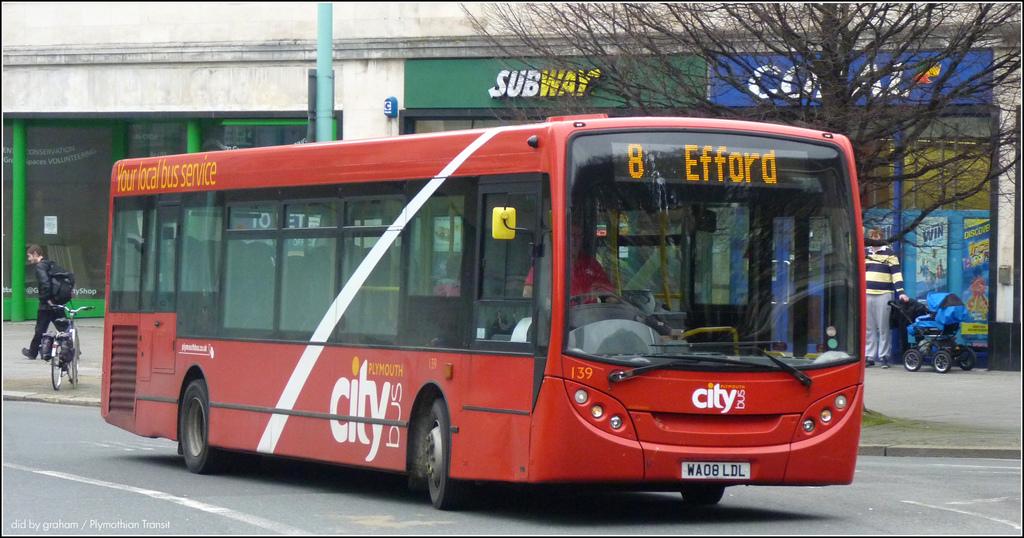Where is this bus headed?
Your answer should be compact. Efford. What is the route number?
Give a very brief answer. 8. 